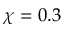Convert formula to latex. <formula><loc_0><loc_0><loc_500><loc_500>\chi = 0 . 3</formula> 